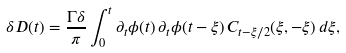<formula> <loc_0><loc_0><loc_500><loc_500>\delta D ( t ) = \frac { \Gamma \delta } { \pi } \int _ { 0 } ^ { t } \partial _ { t } \phi ( t ) \, \partial _ { t } \phi ( t - \xi ) \, C _ { t - \xi / 2 } ( \xi , - \xi ) \, d \xi ,</formula> 